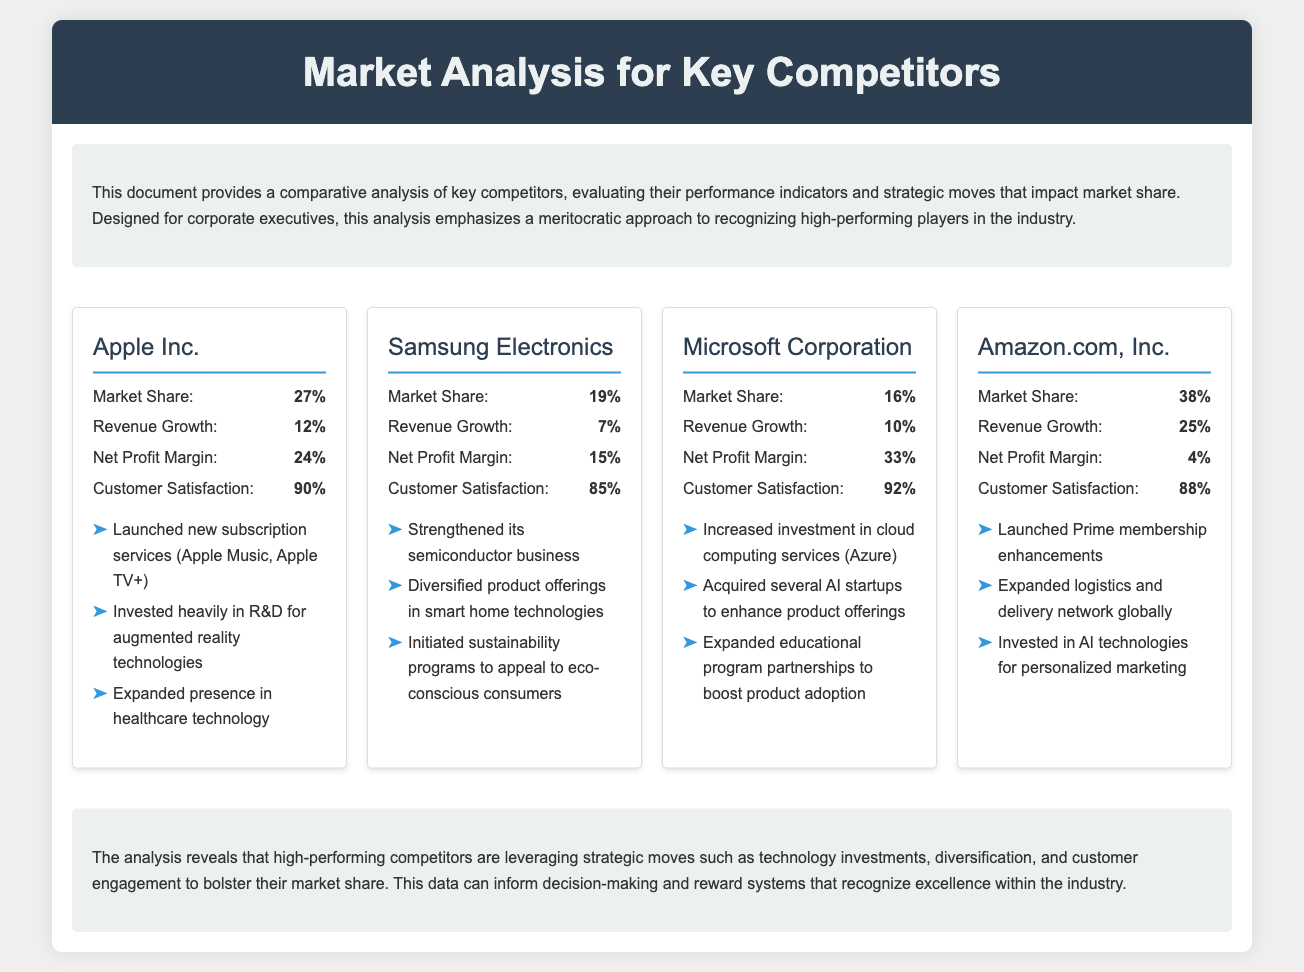What is Apple's market share? The document states that Apple's market share is 27%.
Answer: 27% What is Amazon's revenue growth percentage? Amazon's revenue growth percentage is provided as 25%.
Answer: 25% Which competitor has the highest net profit margin? The competitor with the highest net profit margin is identified as Microsoft Corporation with 33%.
Answer: 33% What strategic move did Samsung Electronics initiate? Samsung Electronics initiated sustainability programs to appeal to eco-conscious consumers.
Answer: Sustainability programs Which company has the highest customer satisfaction rating? The document lists Microsoft Corporation as having the highest customer satisfaction at 92%.
Answer: 92% What is the revenue growth for Apple Inc.? Apple Inc.'s revenue growth is mentioned as 12%.
Answer: 12% Which company has the lowest net profit margin? Amazon.com, Inc. has the lowest net profit margin at 4%.
Answer: 4% What main technological area did Apple invest in? Apple invested heavily in augmented reality technologies.
Answer: Augmented reality technologies How many strategic moves are listed for Microsoft Corporation? The document provides three strategic moves for Microsoft Corporation.
Answer: Three 